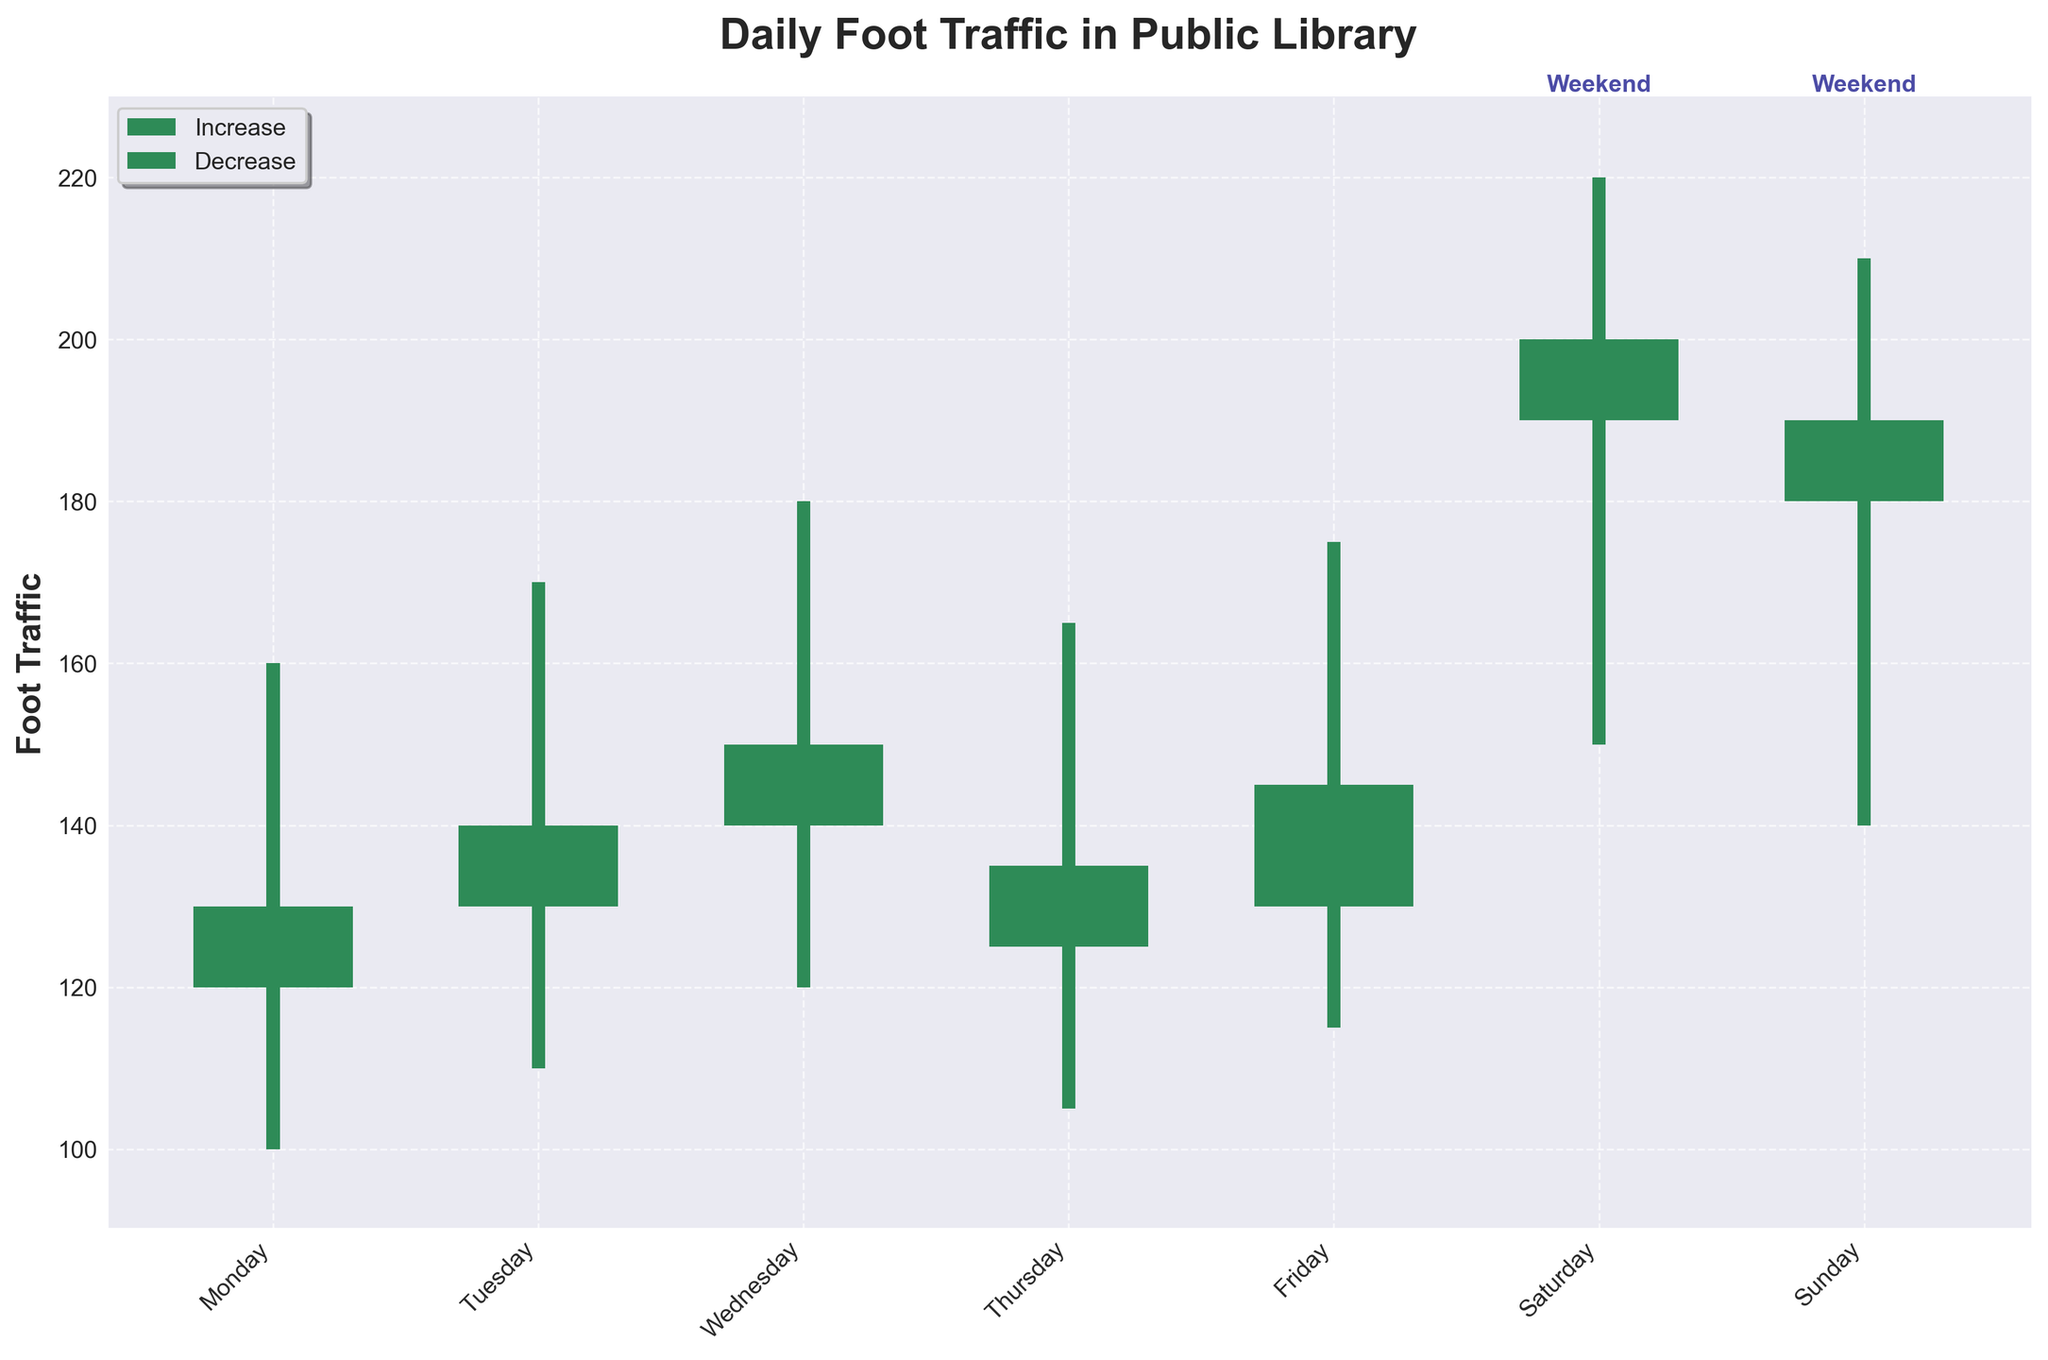What's the title of the figure? The title is prominently displayed at the top of the plot.
Answer: Daily Foot Traffic in Public Library Which day has the highest foot traffic? The highest foot traffic can be identified by the tallest candlestick, which occurs on Saturday, reaching a high of 220.
Answer: Saturday How does the foot traffic change from Monday to Wednesday? To find the changes, look at the 'Open' and 'Close' values for Monday, Tuesday, and Wednesday. Foot traffic increases from 120 (Open on Monday) to 150 (Close on Wednesday).
Answer: It increases How many days have higher closing foot traffic than opening foot traffic? Count the number of candlesticks where the top is higher than the bottom and colored in seagreen. There are 5 days: Monday, Tuesday, Wednesday, Friday, and Saturday.
Answer: 5 days What is the average closing foot traffic for weekends? Weekends include Saturday and Sunday. The closing values are 200 and 190. The average is calculated as (200 + 190) / 2.
Answer: 195 Which day has the lowest opening foot traffic? The lowest value at the bottom of a candlestick's Open value is on Monday, with an Open of 120.
Answer: Monday Compare the range of foot traffic on Tuesday and Thursday. Which day has more variation? Calculate the range by subtracting the Low from the High for each day. Tuesday: 170 - 110 = 60, Thursday: 165 - 105 = 60. Both have the same variation of 60.
Answer: Both have the same On which days does the foot traffic decrease by the end of the day? Identify candlesticks colored in crimson, indicating a drop, which occurs on Thursday and Sunday.
Answer: Thursday and Sunday What's the sum of the highest foot traffic values for weekdays? Sum the High values from Monday to Friday: 160 + 170 + 180 + 165 + 175 = 850.
Answer: 850 How does the weekend foot traffic generally compare to weekday foot traffic? By looking at the overall height and color of candlesticks, weekends generally show higher foot traffic with more green candlesticks, indicating increases, compared to the weekdays.
Answer: Weekends are higher 